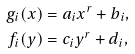Convert formula to latex. <formula><loc_0><loc_0><loc_500><loc_500>g _ { i } ( x ) & = a _ { i } x ^ { r } + b _ { i } , \\ f _ { i } ( y ) & = c _ { i } y ^ { r } + d _ { i } ,</formula> 